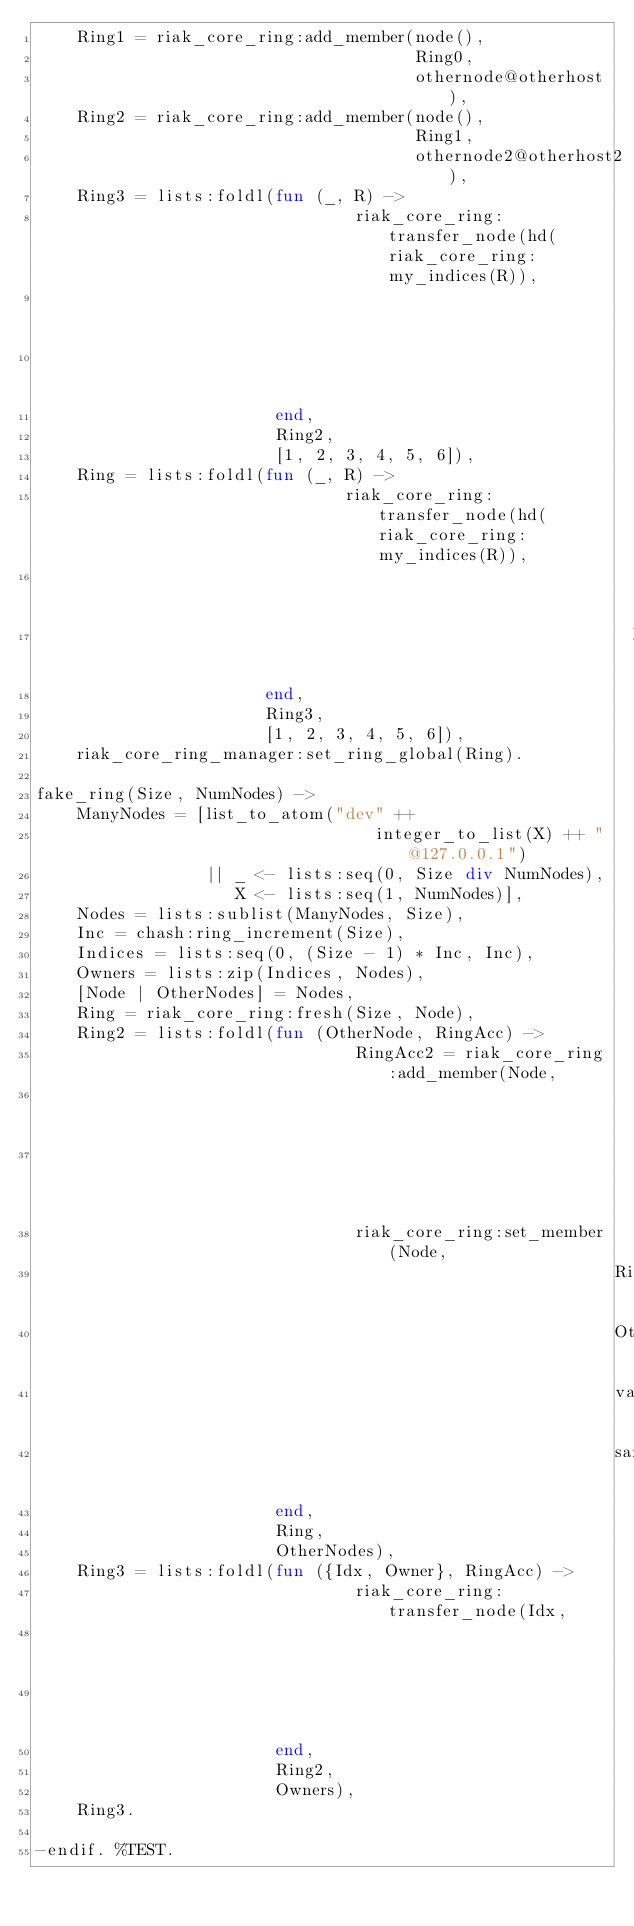Convert code to text. <code><loc_0><loc_0><loc_500><loc_500><_Erlang_>    Ring1 = riak_core_ring:add_member(node(),
                                      Ring0,
                                      othernode@otherhost),
    Ring2 = riak_core_ring:add_member(node(),
                                      Ring1,
                                      othernode2@otherhost2),
    Ring3 = lists:foldl(fun (_, R) ->
                                riak_core_ring:transfer_node(hd(riak_core_ring:my_indices(R)),
                                                             othernode@otherhost,
                                                             R)
                        end,
                        Ring2,
                        [1, 2, 3, 4, 5, 6]),
    Ring = lists:foldl(fun (_, R) ->
                               riak_core_ring:transfer_node(hd(riak_core_ring:my_indices(R)),
                                                            othernode2@otherhost2,
                                                            R)
                       end,
                       Ring3,
                       [1, 2, 3, 4, 5, 6]),
    riak_core_ring_manager:set_ring_global(Ring).

fake_ring(Size, NumNodes) ->
    ManyNodes = [list_to_atom("dev" ++
                                  integer_to_list(X) ++ "@127.0.0.1")
                 || _ <- lists:seq(0, Size div NumNodes),
                    X <- lists:seq(1, NumNodes)],
    Nodes = lists:sublist(ManyNodes, Size),
    Inc = chash:ring_increment(Size),
    Indices = lists:seq(0, (Size - 1) * Inc, Inc),
    Owners = lists:zip(Indices, Nodes),
    [Node | OtherNodes] = Nodes,
    Ring = riak_core_ring:fresh(Size, Node),
    Ring2 = lists:foldl(fun (OtherNode, RingAcc) ->
                                RingAcc2 = riak_core_ring:add_member(Node,
                                                                     RingAcc,
                                                                     OtherNode),
                                riak_core_ring:set_member(Node,
                                                          RingAcc2,
                                                          OtherNode,
                                                          valid,
                                                          same_vclock)
                        end,
                        Ring,
                        OtherNodes),
    Ring3 = lists:foldl(fun ({Idx, Owner}, RingAcc) ->
                                riak_core_ring:transfer_node(Idx,
                                                             Owner,
                                                             RingAcc)
                        end,
                        Ring2,
                        Owners),
    Ring3.

-endif. %TEST.
</code> 